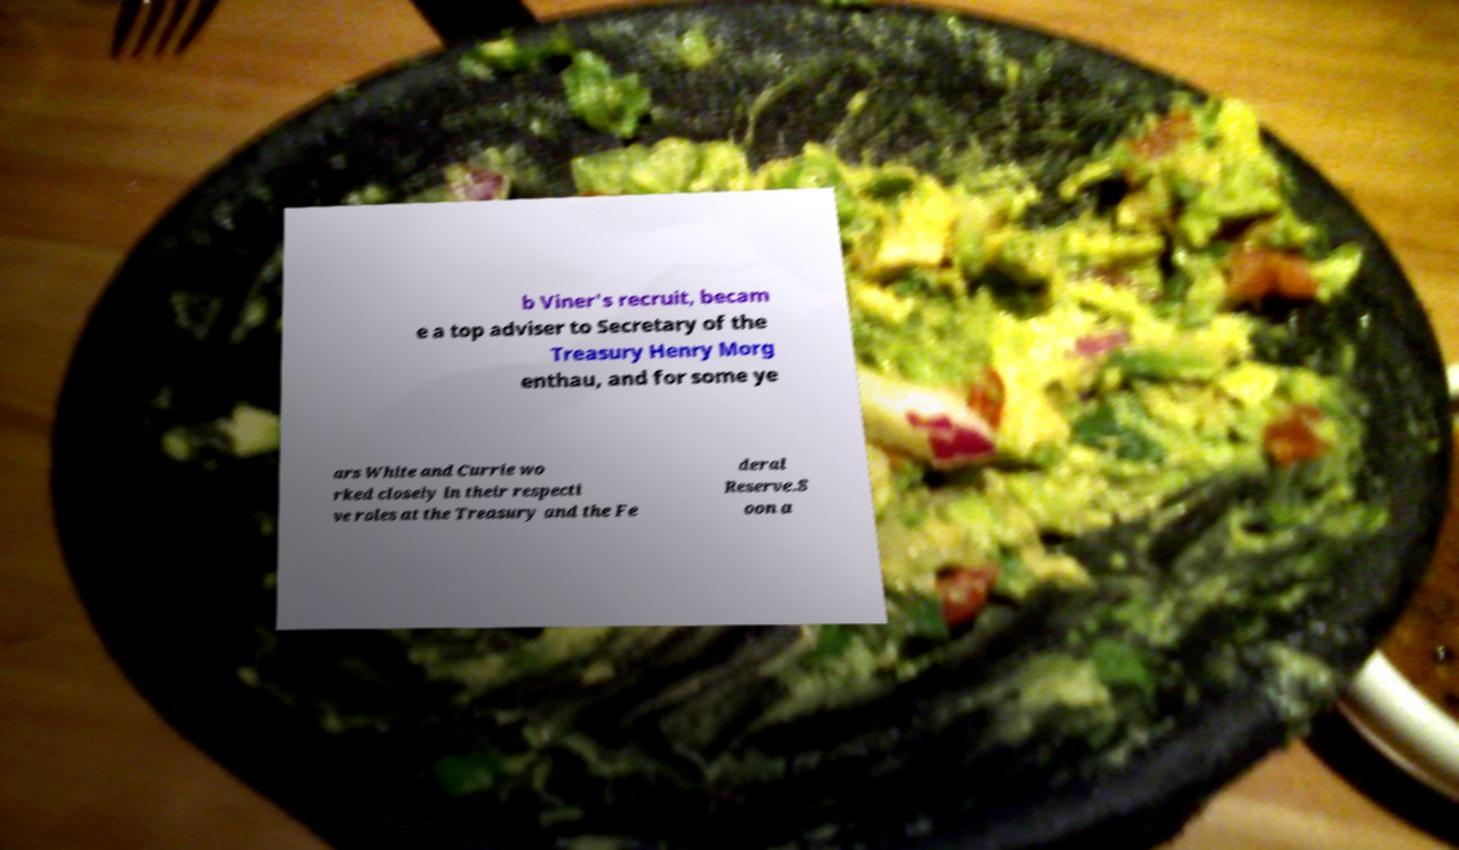Could you assist in decoding the text presented in this image and type it out clearly? b Viner's recruit, becam e a top adviser to Secretary of the Treasury Henry Morg enthau, and for some ye ars White and Currie wo rked closely in their respecti ve roles at the Treasury and the Fe deral Reserve.S oon a 